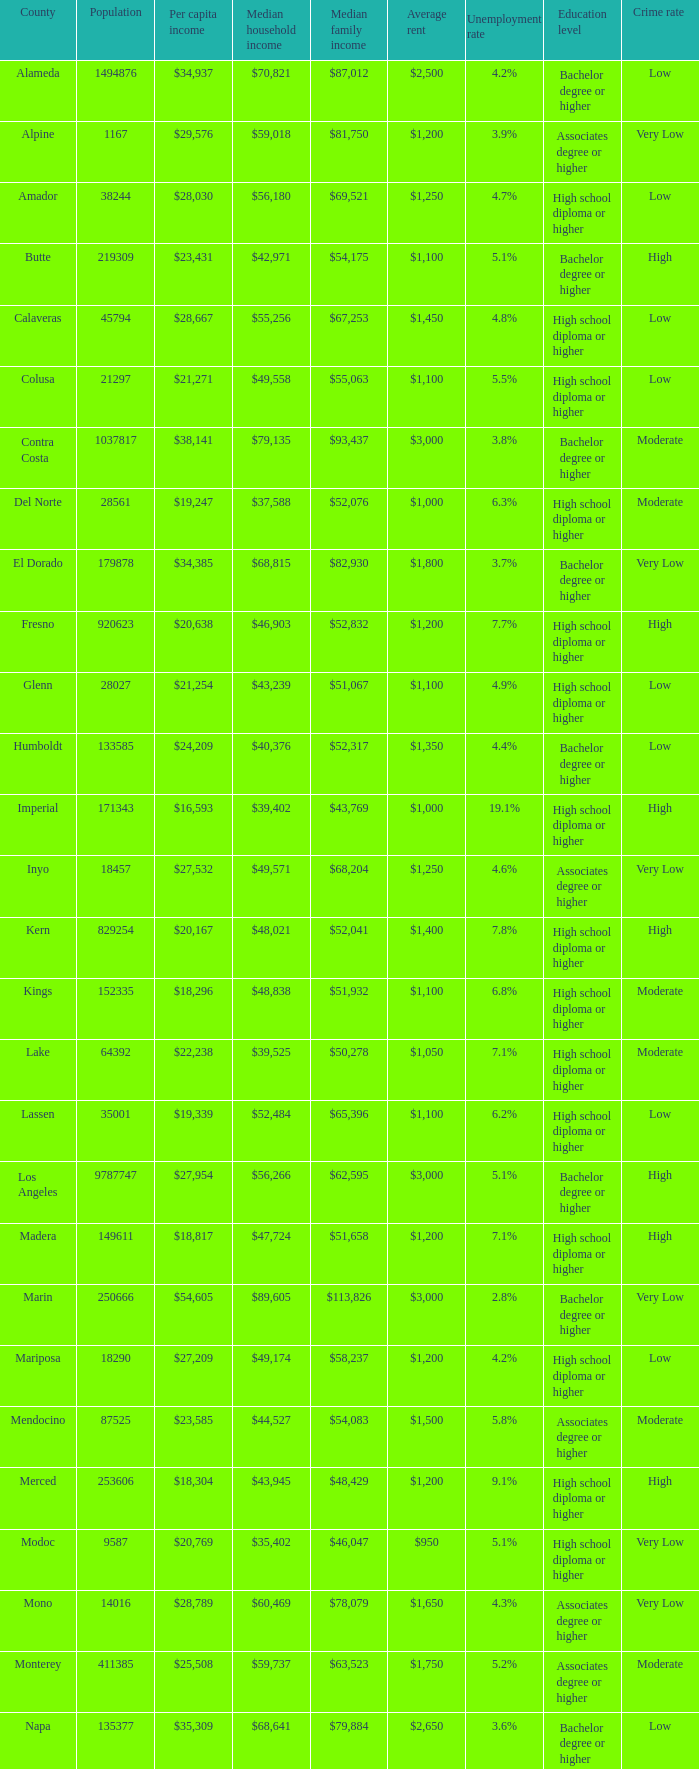Name the median family income for riverside $65,457. Could you parse the entire table? {'header': ['County', 'Population', 'Per capita income', 'Median household income', 'Median family income', 'Average rent', 'Unemployment rate', 'Education level', 'Crime rate '], 'rows': [['Alameda', '1494876', '$34,937', '$70,821', '$87,012', '$2,500', '4.2%', 'Bachelor degree or higher', 'Low'], ['Alpine', '1167', '$29,576', '$59,018', '$81,750', '$1,200', '3.9%', 'Associates degree or higher', 'Very Low'], ['Amador', '38244', '$28,030', '$56,180', '$69,521', '$1,250', '4.7%', 'High school diploma or higher', 'Low'], ['Butte', '219309', '$23,431', '$42,971', '$54,175', '$1,100', '5.1%', 'Bachelor degree or higher', 'High'], ['Calaveras', '45794', '$28,667', '$55,256', '$67,253', '$1,450', '4.8%', 'High school diploma or higher', 'Low'], ['Colusa', '21297', '$21,271', '$49,558', '$55,063', '$1,100', '5.5%', 'High school diploma or higher', 'Low'], ['Contra Costa', '1037817', '$38,141', '$79,135', '$93,437', '$3,000', '3.8%', 'Bachelor degree or higher', 'Moderate'], ['Del Norte', '28561', '$19,247', '$37,588', '$52,076', '$1,000', '6.3%', 'High school diploma or higher', 'Moderate'], ['El Dorado', '179878', '$34,385', '$68,815', '$82,930', '$1,800', '3.7%', 'Bachelor degree or higher', 'Very Low'], ['Fresno', '920623', '$20,638', '$46,903', '$52,832', '$1,200', '7.7%', 'High school diploma or higher', 'High'], ['Glenn', '28027', '$21,254', '$43,239', '$51,067', '$1,100', '4.9%', 'High school diploma or higher', 'Low'], ['Humboldt', '133585', '$24,209', '$40,376', '$52,317', '$1,350', '4.4%', 'Bachelor degree or higher', 'Low'], ['Imperial', '171343', '$16,593', '$39,402', '$43,769', '$1,000', '19.1%', 'High school diploma or higher', 'High'], ['Inyo', '18457', '$27,532', '$49,571', '$68,204', '$1,250', '4.6%', 'Associates degree or higher', 'Very Low'], ['Kern', '829254', '$20,167', '$48,021', '$52,041', '$1,400', '7.8%', 'High school diploma or higher', 'High'], ['Kings', '152335', '$18,296', '$48,838', '$51,932', '$1,100', '6.8%', 'High school diploma or higher', 'Moderate'], ['Lake', '64392', '$22,238', '$39,525', '$50,278', '$1,050', '7.1%', 'High school diploma or higher', 'Moderate'], ['Lassen', '35001', '$19,339', '$52,484', '$65,396', '$1,100', '6.2%', 'High school diploma or higher', 'Low'], ['Los Angeles', '9787747', '$27,954', '$56,266', '$62,595', '$3,000', '5.1%', 'Bachelor degree or higher', 'High'], ['Madera', '149611', '$18,817', '$47,724', '$51,658', '$1,200', '7.1%', 'High school diploma or higher', 'High'], ['Marin', '250666', '$54,605', '$89,605', '$113,826', '$3,000', '2.8%', 'Bachelor degree or higher', 'Very Low'], ['Mariposa', '18290', '$27,209', '$49,174', '$58,237', '$1,200', '4.2%', 'High school diploma or higher', 'Low'], ['Mendocino', '87525', '$23,585', '$44,527', '$54,083', '$1,500', '5.8%', 'Associates degree or higher', 'Moderate'], ['Merced', '253606', '$18,304', '$43,945', '$48,429', '$1,200', '9.1%', 'High school diploma or higher', 'High'], ['Modoc', '9587', '$20,769', '$35,402', '$46,047', '$950', '5.1%', 'High school diploma or higher', 'Very Low'], ['Mono', '14016', '$28,789', '$60,469', '$78,079', '$1,650', '4.3%', 'Associates degree or higher', 'Very Low'], ['Monterey', '411385', '$25,508', '$59,737', '$63,523', '$1,750', '5.2%', 'Associates degree or higher', 'Moderate'], ['Napa', '135377', '$35,309', '$68,641', '$79,884', '$2,650', '3.6%', 'Bachelor degree or higher', 'Low'], ['Nevada', '98392', '$31,607', '$58,077', '$69,807', '$1,450', '4.3%', 'Associates degree or higher', 'Low'], ['Orange', '2989948', '$34,416', '$75,762', '$85,009', '$2,850', '3.2%', 'Bachelor degree or higher', 'Moderate'], ['Placer', '343554', '$35,583', '$74,645', '$90,446', '$2,300', '3.4%', 'Bachelor degree or higher', 'Very Low'], ['Plumas', '20192', '$28,104', '$44,151', '$53,128', '$1,550', '4.5%', 'Associates degree or higher', 'Low'], ['Riverside', '2154844', '$24,516', '$58,365', '$65,457', '$2,000', '5.2%', 'High school diploma or higher', 'High'], ['Sacramento', '1408480', '$27,180', '$56,553', '$65,720', '$1,800', '4.5%', 'Bachelor degree or higher', 'Moderate'], ['San Benito', '54873', '$26,300', '$65,570', '$73,150', '$1,850', '4.1%', 'Associates degree or higher', 'Low'], ['San Bernardino', '2023452', '$21,932', '$55,853', '$61,525', '$1,350', '5.6%', 'High school diploma or higher', 'High'], ['San Diego', '3060849', '$30,955', '$63,857', '$74,633', '$2,750', '3.7%', 'Bachelor degree or higher', 'Moderate'], ['San Francisco', '797983', '$46,777', '$72,947', '$87,329', '$3,750', '2.6%', 'Bachelor degree or higher', 'Very Low'], ['San Joaquin', '680277', '$22,857', '$53,764', '$60,725', '$1,450', '6.0%', 'High school diploma or higher', 'High'], ['San Luis Obispo', '267871', '$30,204', '$58,630', '$74,841', '$1,950', '3.6%', 'Bachelor degree or higher', 'Low'], ['San Mateo', '711622', '$45,346', '$87,633', '$104,370', '$3,250', '3.0%', 'Bachelor degree or higher', 'Very Low'], ['Santa Barbara', '419793', '$30,330', '$61,896', '$71,695', '$2,450', '4.1%', 'Bachelor degree or higher', 'Moderate'], ['Santa Clara', '1762754', '$40,698', '$89,064', '$103,255', '$2,900', '3.3%', 'Bachelor degree or higher', 'Low'], ['Santa Cruz', '259402', '$32,975', '$66,030', '$80,572', '$2,400', '4.2%', 'Bachelor degree or higher', 'Moderate'], ['Shasta', '177231', '$23,691', '$44,058', '$55,250', '$1,250', '5.4%', 'High school diploma or higher', 'High'], ['Sierra', '3277', '$26,137', '$50,308', '$56,469', '$1,300', '4.1%', 'Associates degree or higher', 'Very Low'], ['Siskiyou', '44687', '$22,335', '$37,865', '$47,632', '$1,050', '5.0%', 'High school diploma or higher', 'Moderate'], ['Solano', '411620', '$29,367', '$69,914', '$79,316', '$2,400', '4.2%', 'Associates degree or higher', 'Moderate'], ['Sonoma', '478551', '$33,119', '$64,343', '$78,227', '$2,400', '3.7%', 'Bachelor degree or higher', 'Moderate'], ['Stanislaus', '512469', '$21,820', '$50,671', '$56,996', '$1,350', '7.3%', 'High school diploma or higher', 'High'], ['Sutter', '94192', '$22,464', '$50,010', '$54,737', '$1,200', '4.7%', 'High school diploma or higher', 'Moderate'], ['Tehama', '62985', '$20,689', '$38,753', '$46,805', '$1,100', '6.0%', 'High school diploma or higher', 'High'], ['Trinity', '13711', '$22,551', '$37,672', '$46,980', '$1,100', '4.6%', 'High school diploma or higher', 'Low'], ['Tulare', '436234', '$17,986', '$43,550', '$46,881', '$1,150', '8.0%', 'High school diploma or higher', 'High'], ['Tuolumne', '55736', '$26,084', '$47,359', '$59,710', '$1,450', '5.3%', 'Associates degree or higher', 'Low'], ['Ventura', '815745', '$32,740', '$76,728', '$86,321', '$2,800', '3.6%', 'Bachelor degree or higher', 'Moderate'], ['Yolo', '198889', '$28,631', '$57,920', '$74,991', '$1,850', '4.3%', 'Bachelor degree or higher', 'High']]} 